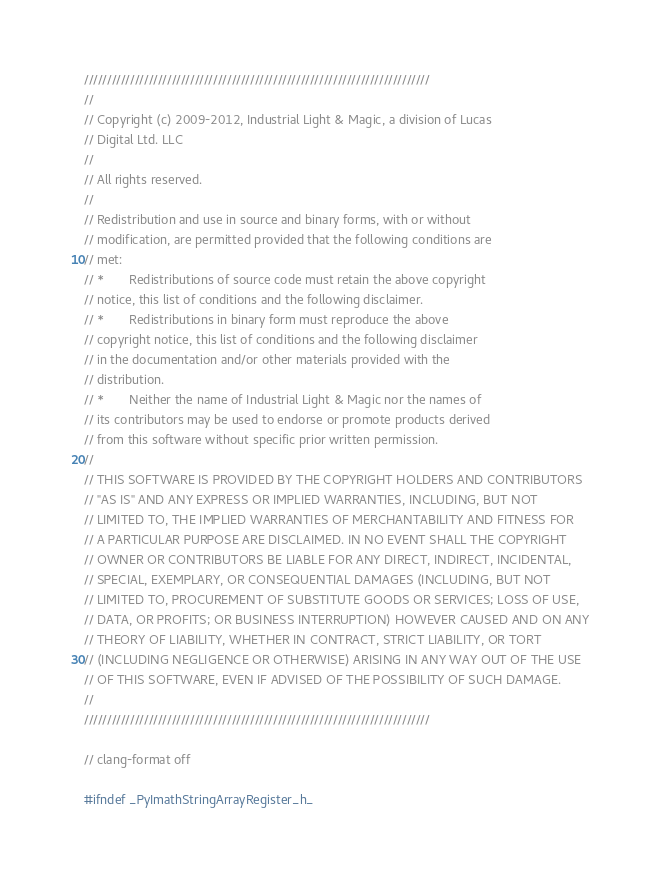<code> <loc_0><loc_0><loc_500><loc_500><_C_>///////////////////////////////////////////////////////////////////////////
//
// Copyright (c) 2009-2012, Industrial Light & Magic, a division of Lucas
// Digital Ltd. LLC
//
// All rights reserved.
//
// Redistribution and use in source and binary forms, with or without
// modification, are permitted provided that the following conditions are
// met:
// *       Redistributions of source code must retain the above copyright
// notice, this list of conditions and the following disclaimer.
// *       Redistributions in binary form must reproduce the above
// copyright notice, this list of conditions and the following disclaimer
// in the documentation and/or other materials provided with the
// distribution.
// *       Neither the name of Industrial Light & Magic nor the names of
// its contributors may be used to endorse or promote products derived
// from this software without specific prior written permission.
//
// THIS SOFTWARE IS PROVIDED BY THE COPYRIGHT HOLDERS AND CONTRIBUTORS
// "AS IS" AND ANY EXPRESS OR IMPLIED WARRANTIES, INCLUDING, BUT NOT
// LIMITED TO, THE IMPLIED WARRANTIES OF MERCHANTABILITY AND FITNESS FOR
// A PARTICULAR PURPOSE ARE DISCLAIMED. IN NO EVENT SHALL THE COPYRIGHT
// OWNER OR CONTRIBUTORS BE LIABLE FOR ANY DIRECT, INDIRECT, INCIDENTAL,
// SPECIAL, EXEMPLARY, OR CONSEQUENTIAL DAMAGES (INCLUDING, BUT NOT
// LIMITED TO, PROCUREMENT OF SUBSTITUTE GOODS OR SERVICES; LOSS OF USE,
// DATA, OR PROFITS; OR BUSINESS INTERRUPTION) HOWEVER CAUSED AND ON ANY
// THEORY OF LIABILITY, WHETHER IN CONTRACT, STRICT LIABILITY, OR TORT
// (INCLUDING NEGLIGENCE OR OTHERWISE) ARISING IN ANY WAY OUT OF THE USE
// OF THIS SOFTWARE, EVEN IF ADVISED OF THE POSSIBILITY OF SUCH DAMAGE.
//
///////////////////////////////////////////////////////////////////////////

// clang-format off

#ifndef _PyImathStringArrayRegister_h_</code> 